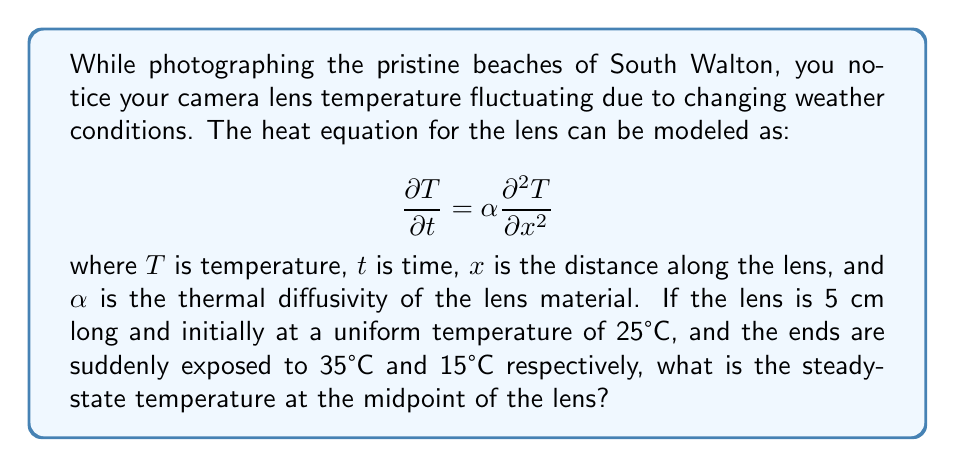Give your solution to this math problem. To solve this problem, we need to follow these steps:

1) For the steady-state solution, the temperature doesn't change with time. So, we set $\frac{\partial T}{\partial t} = 0$:

   $$0 = \alpha \frac{\partial^2 T}{\partial x^2}$$

2) Integrating twice with respect to $x$:

   $$T(x) = Ax + B$$

   where $A$ and $B$ are constants to be determined from the boundary conditions.

3) The boundary conditions are:
   At $x = 0$, $T = 35°C$
   At $x = 5$ cm, $T = 15°C$

4) Applying these conditions:
   At $x = 0$: $35 = B$
   At $x = 5$: $15 = 5A + 35$

5) From the second equation:
   $15 - 35 = 5A$
   $-20 = 5A$
   $A = -4$

6) So our steady-state temperature distribution is:

   $$T(x) = -4x + 35$$

7) The midpoint of the lens is at $x = 2.5$ cm. Substituting this into our equation:

   $$T(2.5) = -4(2.5) + 35 = -10 + 35 = 25°C$$

Therefore, the steady-state temperature at the midpoint of the lens is 25°C.
Answer: 25°C 